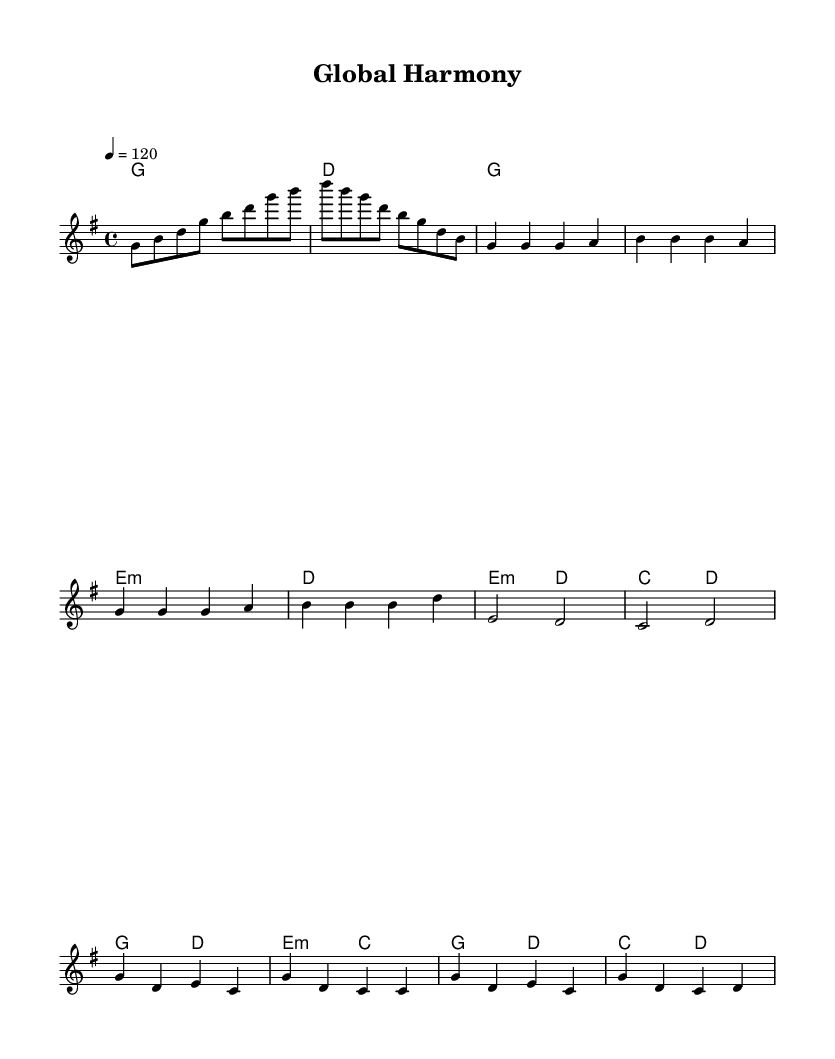What is the key signature of this music? The key signature is G major, which has one sharp (F#). This can be determined by inspecting the key signature at the beginning of the score.
Answer: G major What is the time signature of this music? The time signature is 4/4, which is indicated at the beginning of the score after the key signature. It signifies that there are four beats in each measure and the quarter note gets one beat.
Answer: 4/4 What is the tempo of this music piece? The tempo is 120 beats per minute, as stated in the tempo marking with "4 = 120." This indicates how fast the piece should be played, with each quarter note receiving one beat at this rate.
Answer: 120 How many measures are in the melody? The melody has a total of 14 measures. This can be calculated by counting the number of vertical lines (bar lines) in the melody section, which denote the start and end of each measure.
Answer: 14 What is the structure of this piece based on the sections? The structure includes an Intro, Verse 1, Pre-Chorus, and Chorus. By examining the notation and grouping of measures, these sections are clearly defined within the piece, often changing in both texture and thematic material.
Answer: Intro, Verse 1, Pre-Chorus, Chorus Which chord appears in the pre-chorus section? The chords in the pre-chorus section are E minor and D. By checking the chord symbols above the notes in that specific section, they can be identified as those two chords.
Answer: E minor, D What musical style does this piece represent? This music represents K-pop, identified through its structure, rhythmic feel, and the typical arrangement seen in modern pop music styles, which often includes collaborations with international artists.
Answer: K-pop 